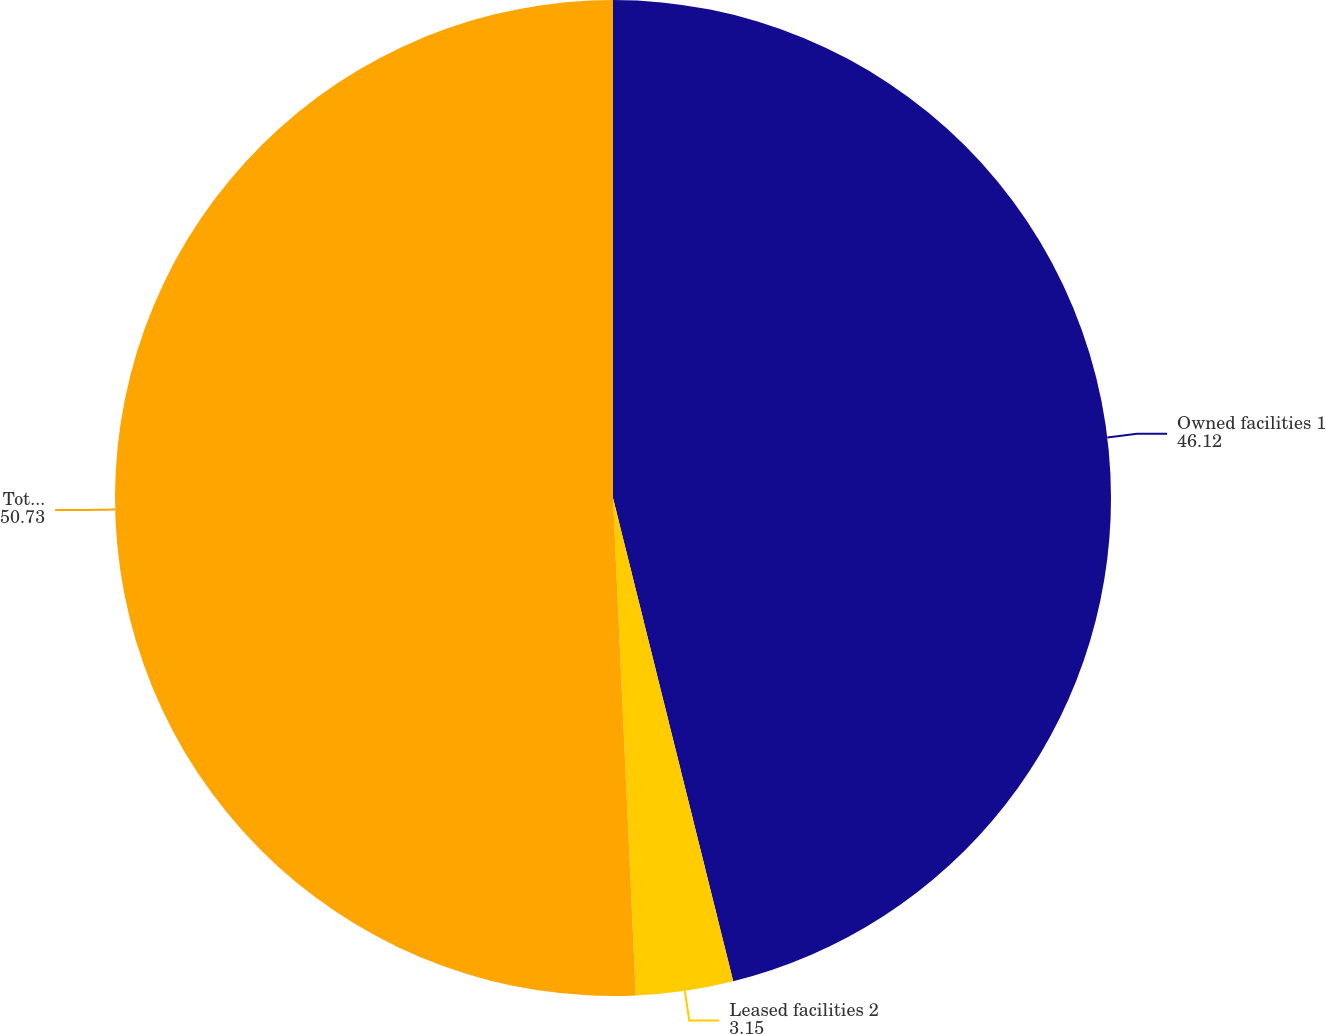Convert chart. <chart><loc_0><loc_0><loc_500><loc_500><pie_chart><fcel>Owned facilities 1<fcel>Leased facilities 2<fcel>Total facilities<nl><fcel>46.12%<fcel>3.15%<fcel>50.73%<nl></chart> 